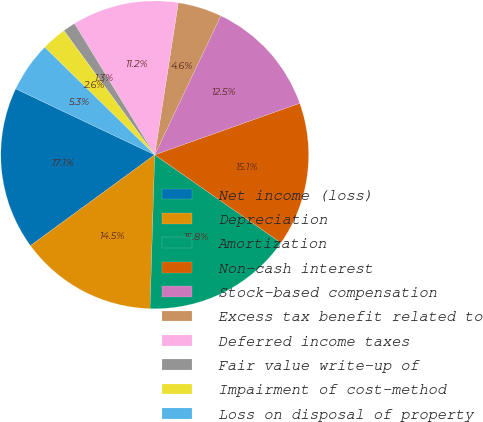<chart> <loc_0><loc_0><loc_500><loc_500><pie_chart><fcel>Net income (loss)<fcel>Depreciation<fcel>Amortization<fcel>Non-cash interest<fcel>Stock-based compensation<fcel>Excess tax benefit related to<fcel>Deferred income taxes<fcel>Fair value write-up of<fcel>Impairment of cost-method<fcel>Loss on disposal of property<nl><fcel>17.1%<fcel>14.47%<fcel>15.79%<fcel>15.13%<fcel>12.5%<fcel>4.61%<fcel>11.18%<fcel>1.32%<fcel>2.63%<fcel>5.26%<nl></chart> 